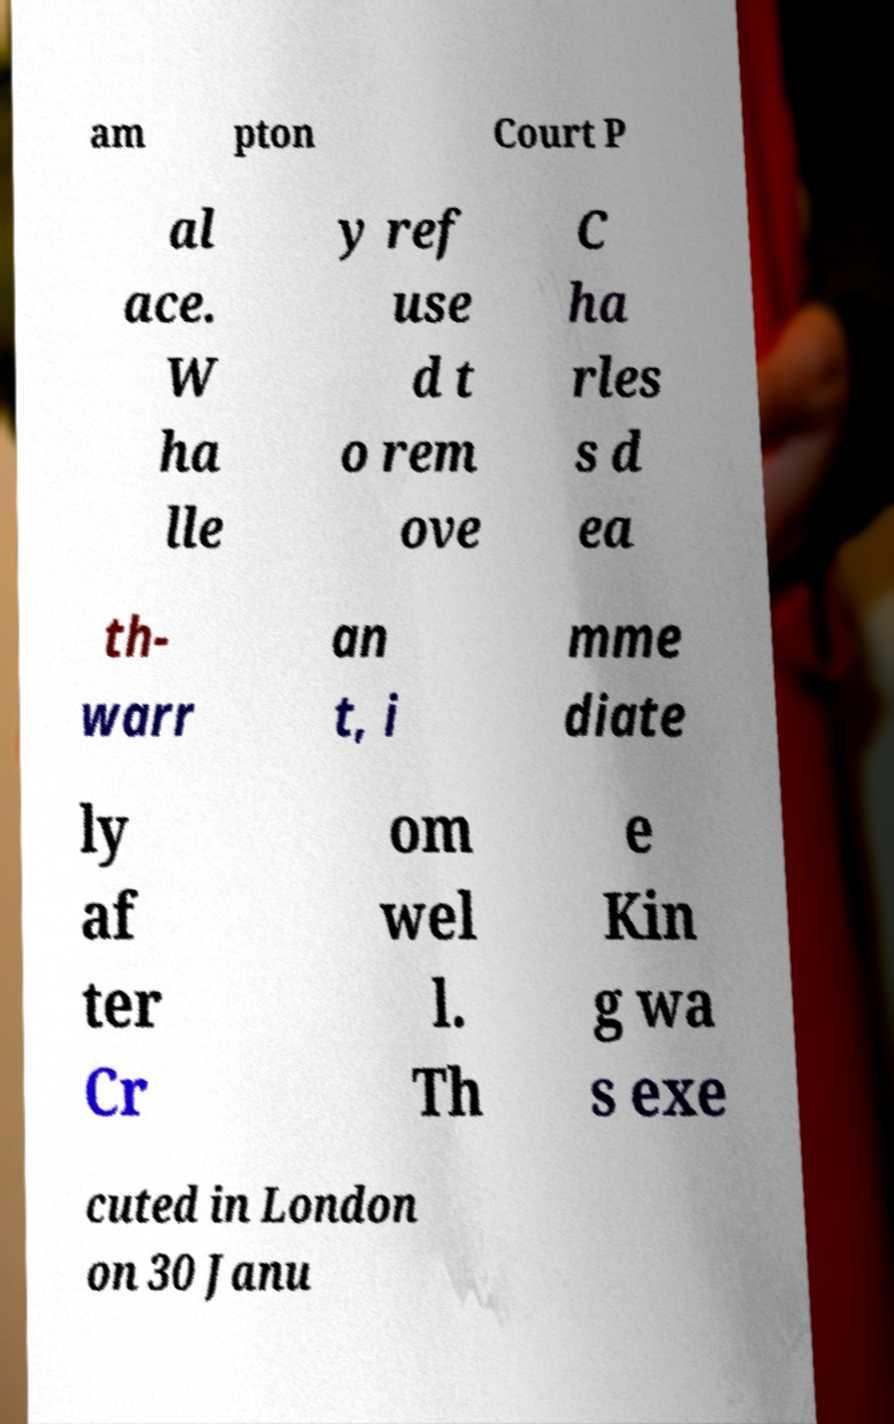Could you extract and type out the text from this image? am pton Court P al ace. W ha lle y ref use d t o rem ove C ha rles s d ea th- warr an t, i mme diate ly af ter Cr om wel l. Th e Kin g wa s exe cuted in London on 30 Janu 